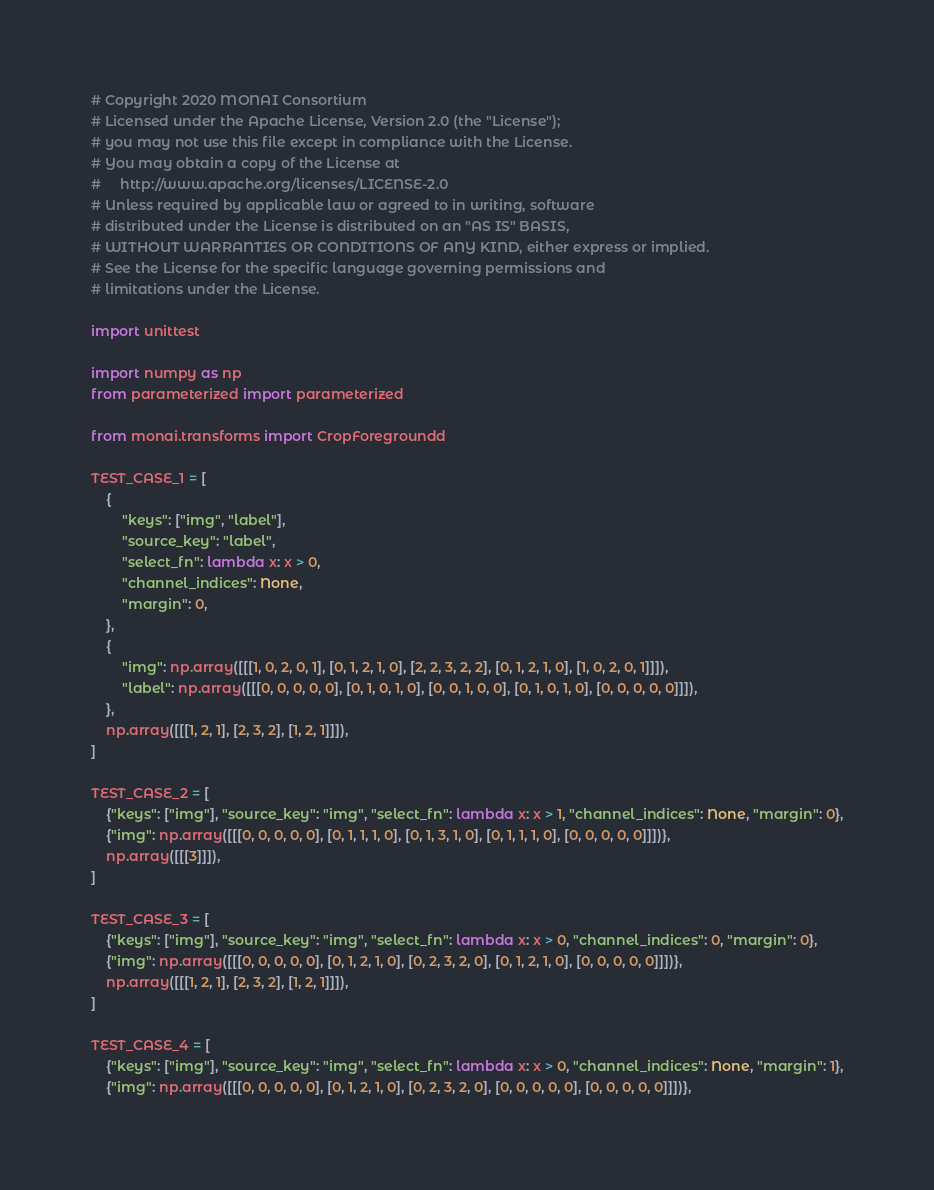Convert code to text. <code><loc_0><loc_0><loc_500><loc_500><_Python_># Copyright 2020 MONAI Consortium
# Licensed under the Apache License, Version 2.0 (the "License");
# you may not use this file except in compliance with the License.
# You may obtain a copy of the License at
#     http://www.apache.org/licenses/LICENSE-2.0
# Unless required by applicable law or agreed to in writing, software
# distributed under the License is distributed on an "AS IS" BASIS,
# WITHOUT WARRANTIES OR CONDITIONS OF ANY KIND, either express or implied.
# See the License for the specific language governing permissions and
# limitations under the License.

import unittest

import numpy as np
from parameterized import parameterized

from monai.transforms import CropForegroundd

TEST_CASE_1 = [
    {
        "keys": ["img", "label"],
        "source_key": "label",
        "select_fn": lambda x: x > 0,
        "channel_indices": None,
        "margin": 0,
    },
    {
        "img": np.array([[[1, 0, 2, 0, 1], [0, 1, 2, 1, 0], [2, 2, 3, 2, 2], [0, 1, 2, 1, 0], [1, 0, 2, 0, 1]]]),
        "label": np.array([[[0, 0, 0, 0, 0], [0, 1, 0, 1, 0], [0, 0, 1, 0, 0], [0, 1, 0, 1, 0], [0, 0, 0, 0, 0]]]),
    },
    np.array([[[1, 2, 1], [2, 3, 2], [1, 2, 1]]]),
]

TEST_CASE_2 = [
    {"keys": ["img"], "source_key": "img", "select_fn": lambda x: x > 1, "channel_indices": None, "margin": 0},
    {"img": np.array([[[0, 0, 0, 0, 0], [0, 1, 1, 1, 0], [0, 1, 3, 1, 0], [0, 1, 1, 1, 0], [0, 0, 0, 0, 0]]])},
    np.array([[[3]]]),
]

TEST_CASE_3 = [
    {"keys": ["img"], "source_key": "img", "select_fn": lambda x: x > 0, "channel_indices": 0, "margin": 0},
    {"img": np.array([[[0, 0, 0, 0, 0], [0, 1, 2, 1, 0], [0, 2, 3, 2, 0], [0, 1, 2, 1, 0], [0, 0, 0, 0, 0]]])},
    np.array([[[1, 2, 1], [2, 3, 2], [1, 2, 1]]]),
]

TEST_CASE_4 = [
    {"keys": ["img"], "source_key": "img", "select_fn": lambda x: x > 0, "channel_indices": None, "margin": 1},
    {"img": np.array([[[0, 0, 0, 0, 0], [0, 1, 2, 1, 0], [0, 2, 3, 2, 0], [0, 0, 0, 0, 0], [0, 0, 0, 0, 0]]])},</code> 